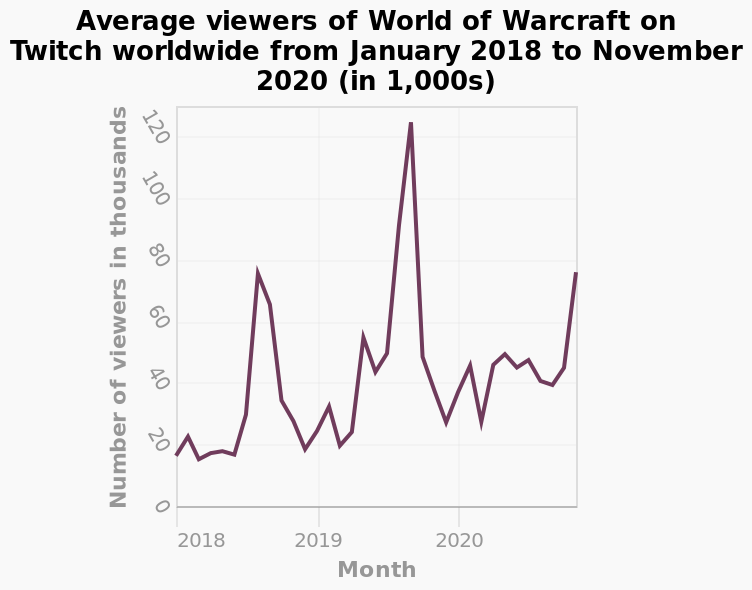<image>
How many viewers did World of Warcraft have during its peak in 2019-2020? World of Warcraft had over 120,000 viewers during its peak in 2019-2020. Offer a thorough analysis of the image. The amount of people who viewed World of Warcraft during 2018-2019 had peaked to just under 80,000, then peaked again during 2019-2020 to over 120,000 views. please describe the details of the chart Average viewers of World of Warcraft on Twitch worldwide from January 2018 to November 2020 (in 1,000s) is a line chart. There is a linear scale of range 0 to 120 along the y-axis, labeled Number of viewers in thousands. There is a linear scale from 2018 to 2020 on the x-axis, labeled Month. What is the maximum value on the y-axis of the line chart? The maximum value on the y-axis of the line chart is 120,000. When did World of Warcraft experience its highest peak viewership? World of Warcraft experienced its highest peak viewership during 2019-2020. 